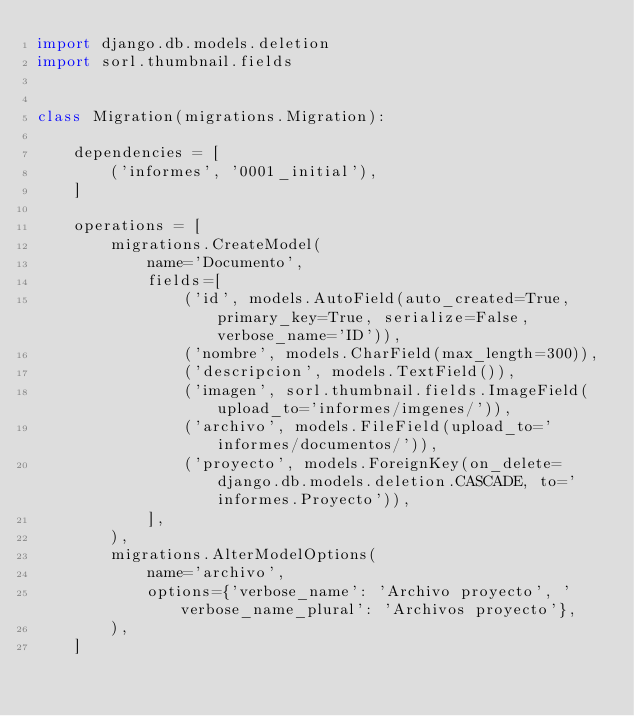Convert code to text. <code><loc_0><loc_0><loc_500><loc_500><_Python_>import django.db.models.deletion
import sorl.thumbnail.fields


class Migration(migrations.Migration):

    dependencies = [
        ('informes', '0001_initial'),
    ]

    operations = [
        migrations.CreateModel(
            name='Documento',
            fields=[
                ('id', models.AutoField(auto_created=True, primary_key=True, serialize=False, verbose_name='ID')),
                ('nombre', models.CharField(max_length=300)),
                ('descripcion', models.TextField()),
                ('imagen', sorl.thumbnail.fields.ImageField(upload_to='informes/imgenes/')),
                ('archivo', models.FileField(upload_to='informes/documentos/')),
                ('proyecto', models.ForeignKey(on_delete=django.db.models.deletion.CASCADE, to='informes.Proyecto')),
            ],
        ),
        migrations.AlterModelOptions(
            name='archivo',
            options={'verbose_name': 'Archivo proyecto', 'verbose_name_plural': 'Archivos proyecto'},
        ),
    ]
</code> 